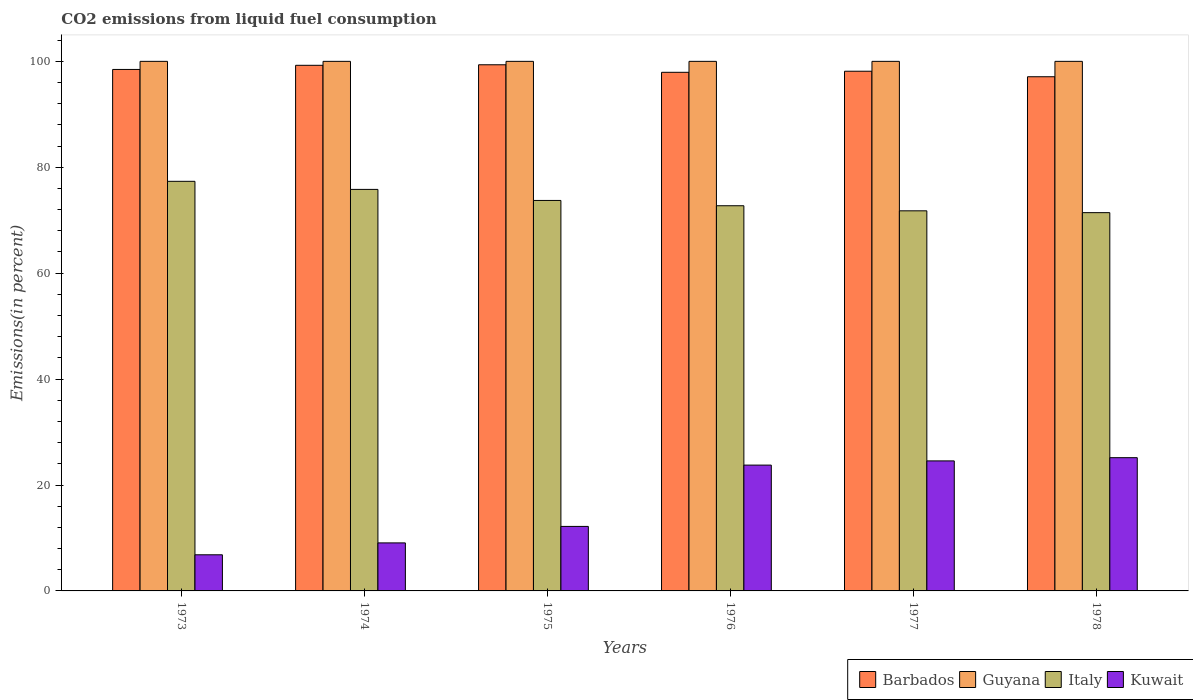How many different coloured bars are there?
Provide a succinct answer. 4. How many groups of bars are there?
Your response must be concise. 6. Are the number of bars on each tick of the X-axis equal?
Your response must be concise. Yes. How many bars are there on the 5th tick from the right?
Ensure brevity in your answer.  4. What is the label of the 6th group of bars from the left?
Provide a short and direct response. 1978. What is the total CO2 emitted in Guyana in 1973?
Offer a very short reply. 100. Across all years, what is the maximum total CO2 emitted in Italy?
Keep it short and to the point. 77.35. Across all years, what is the minimum total CO2 emitted in Kuwait?
Provide a succinct answer. 6.82. In which year was the total CO2 emitted in Barbados maximum?
Make the answer very short. 1975. In which year was the total CO2 emitted in Barbados minimum?
Keep it short and to the point. 1978. What is the total total CO2 emitted in Kuwait in the graph?
Offer a very short reply. 101.55. What is the difference between the total CO2 emitted in Kuwait in 1976 and that in 1977?
Make the answer very short. -0.79. What is the difference between the total CO2 emitted in Guyana in 1976 and the total CO2 emitted in Barbados in 1978?
Offer a terse response. 2.91. What is the average total CO2 emitted in Barbados per year?
Ensure brevity in your answer.  98.37. In the year 1973, what is the difference between the total CO2 emitted in Italy and total CO2 emitted in Guyana?
Keep it short and to the point. -22.65. In how many years, is the total CO2 emitted in Barbados greater than 88 %?
Your answer should be compact. 6. What is the ratio of the total CO2 emitted in Italy in 1974 to that in 1977?
Keep it short and to the point. 1.06. Is the total CO2 emitted in Kuwait in 1974 less than that in 1975?
Provide a short and direct response. Yes. What is the difference between the highest and the second highest total CO2 emitted in Italy?
Ensure brevity in your answer.  1.53. What is the difference between the highest and the lowest total CO2 emitted in Kuwait?
Provide a succinct answer. 18.34. What does the 4th bar from the left in 1978 represents?
Offer a very short reply. Kuwait. What does the 4th bar from the right in 1976 represents?
Provide a succinct answer. Barbados. Are all the bars in the graph horizontal?
Your response must be concise. No. What is the difference between two consecutive major ticks on the Y-axis?
Provide a short and direct response. 20. How many legend labels are there?
Your response must be concise. 4. How are the legend labels stacked?
Ensure brevity in your answer.  Horizontal. What is the title of the graph?
Keep it short and to the point. CO2 emissions from liquid fuel consumption. Does "Papua New Guinea" appear as one of the legend labels in the graph?
Keep it short and to the point. No. What is the label or title of the Y-axis?
Your answer should be very brief. Emissions(in percent). What is the Emissions(in percent) in Barbados in 1973?
Make the answer very short. 98.47. What is the Emissions(in percent) of Italy in 1973?
Keep it short and to the point. 77.35. What is the Emissions(in percent) in Kuwait in 1973?
Your response must be concise. 6.82. What is the Emissions(in percent) of Barbados in 1974?
Offer a terse response. 99.25. What is the Emissions(in percent) in Italy in 1974?
Provide a short and direct response. 75.82. What is the Emissions(in percent) of Kuwait in 1974?
Offer a terse response. 9.07. What is the Emissions(in percent) in Barbados in 1975?
Provide a succinct answer. 99.35. What is the Emissions(in percent) in Italy in 1975?
Provide a short and direct response. 73.73. What is the Emissions(in percent) of Kuwait in 1975?
Make the answer very short. 12.18. What is the Emissions(in percent) of Barbados in 1976?
Offer a very short reply. 97.93. What is the Emissions(in percent) of Guyana in 1976?
Give a very brief answer. 100. What is the Emissions(in percent) of Italy in 1976?
Provide a short and direct response. 72.73. What is the Emissions(in percent) in Kuwait in 1976?
Your response must be concise. 23.76. What is the Emissions(in percent) of Barbados in 1977?
Ensure brevity in your answer.  98.14. What is the Emissions(in percent) in Italy in 1977?
Your answer should be very brief. 71.77. What is the Emissions(in percent) of Kuwait in 1977?
Keep it short and to the point. 24.55. What is the Emissions(in percent) of Barbados in 1978?
Your answer should be very brief. 97.09. What is the Emissions(in percent) in Guyana in 1978?
Give a very brief answer. 100. What is the Emissions(in percent) of Italy in 1978?
Your answer should be compact. 71.43. What is the Emissions(in percent) of Kuwait in 1978?
Offer a terse response. 25.16. Across all years, what is the maximum Emissions(in percent) in Barbados?
Your answer should be compact. 99.35. Across all years, what is the maximum Emissions(in percent) of Guyana?
Keep it short and to the point. 100. Across all years, what is the maximum Emissions(in percent) of Italy?
Make the answer very short. 77.35. Across all years, what is the maximum Emissions(in percent) of Kuwait?
Ensure brevity in your answer.  25.16. Across all years, what is the minimum Emissions(in percent) of Barbados?
Your answer should be very brief. 97.09. Across all years, what is the minimum Emissions(in percent) of Guyana?
Your response must be concise. 100. Across all years, what is the minimum Emissions(in percent) in Italy?
Offer a terse response. 71.43. Across all years, what is the minimum Emissions(in percent) in Kuwait?
Make the answer very short. 6.82. What is the total Emissions(in percent) of Barbados in the graph?
Offer a terse response. 590.24. What is the total Emissions(in percent) of Guyana in the graph?
Ensure brevity in your answer.  600. What is the total Emissions(in percent) of Italy in the graph?
Your response must be concise. 442.84. What is the total Emissions(in percent) of Kuwait in the graph?
Offer a terse response. 101.55. What is the difference between the Emissions(in percent) of Barbados in 1973 and that in 1974?
Make the answer very short. -0.78. What is the difference between the Emissions(in percent) of Guyana in 1973 and that in 1974?
Give a very brief answer. 0. What is the difference between the Emissions(in percent) of Italy in 1973 and that in 1974?
Provide a short and direct response. 1.53. What is the difference between the Emissions(in percent) in Kuwait in 1973 and that in 1974?
Offer a terse response. -2.25. What is the difference between the Emissions(in percent) in Barbados in 1973 and that in 1975?
Keep it short and to the point. -0.88. What is the difference between the Emissions(in percent) of Guyana in 1973 and that in 1975?
Provide a succinct answer. 0. What is the difference between the Emissions(in percent) of Italy in 1973 and that in 1975?
Make the answer very short. 3.61. What is the difference between the Emissions(in percent) in Kuwait in 1973 and that in 1975?
Keep it short and to the point. -5.36. What is the difference between the Emissions(in percent) of Barbados in 1973 and that in 1976?
Ensure brevity in your answer.  0.54. What is the difference between the Emissions(in percent) in Guyana in 1973 and that in 1976?
Provide a succinct answer. 0. What is the difference between the Emissions(in percent) in Italy in 1973 and that in 1976?
Give a very brief answer. 4.61. What is the difference between the Emissions(in percent) of Kuwait in 1973 and that in 1976?
Offer a terse response. -16.94. What is the difference between the Emissions(in percent) of Barbados in 1973 and that in 1977?
Offer a very short reply. 0.34. What is the difference between the Emissions(in percent) of Italy in 1973 and that in 1977?
Make the answer very short. 5.57. What is the difference between the Emissions(in percent) in Kuwait in 1973 and that in 1977?
Offer a very short reply. -17.73. What is the difference between the Emissions(in percent) of Barbados in 1973 and that in 1978?
Your answer should be compact. 1.38. What is the difference between the Emissions(in percent) in Italy in 1973 and that in 1978?
Keep it short and to the point. 5.92. What is the difference between the Emissions(in percent) of Kuwait in 1973 and that in 1978?
Offer a very short reply. -18.34. What is the difference between the Emissions(in percent) in Barbados in 1974 and that in 1975?
Provide a succinct answer. -0.1. What is the difference between the Emissions(in percent) in Guyana in 1974 and that in 1975?
Ensure brevity in your answer.  0. What is the difference between the Emissions(in percent) of Italy in 1974 and that in 1975?
Make the answer very short. 2.09. What is the difference between the Emissions(in percent) of Kuwait in 1974 and that in 1975?
Your answer should be very brief. -3.11. What is the difference between the Emissions(in percent) in Barbados in 1974 and that in 1976?
Keep it short and to the point. 1.32. What is the difference between the Emissions(in percent) in Italy in 1974 and that in 1976?
Your answer should be compact. 3.09. What is the difference between the Emissions(in percent) of Kuwait in 1974 and that in 1976?
Provide a succinct answer. -14.69. What is the difference between the Emissions(in percent) in Barbados in 1974 and that in 1977?
Keep it short and to the point. 1.12. What is the difference between the Emissions(in percent) of Italy in 1974 and that in 1977?
Give a very brief answer. 4.05. What is the difference between the Emissions(in percent) of Kuwait in 1974 and that in 1977?
Your answer should be compact. -15.48. What is the difference between the Emissions(in percent) of Barbados in 1974 and that in 1978?
Provide a short and direct response. 2.16. What is the difference between the Emissions(in percent) of Guyana in 1974 and that in 1978?
Your response must be concise. 0. What is the difference between the Emissions(in percent) of Italy in 1974 and that in 1978?
Make the answer very short. 4.39. What is the difference between the Emissions(in percent) in Kuwait in 1974 and that in 1978?
Your response must be concise. -16.09. What is the difference between the Emissions(in percent) in Barbados in 1975 and that in 1976?
Provide a short and direct response. 1.42. What is the difference between the Emissions(in percent) of Guyana in 1975 and that in 1976?
Your answer should be very brief. 0. What is the difference between the Emissions(in percent) in Italy in 1975 and that in 1976?
Your response must be concise. 1. What is the difference between the Emissions(in percent) in Kuwait in 1975 and that in 1976?
Provide a succinct answer. -11.58. What is the difference between the Emissions(in percent) of Barbados in 1975 and that in 1977?
Offer a very short reply. 1.22. What is the difference between the Emissions(in percent) of Italy in 1975 and that in 1977?
Your response must be concise. 1.96. What is the difference between the Emissions(in percent) in Kuwait in 1975 and that in 1977?
Your answer should be compact. -12.37. What is the difference between the Emissions(in percent) of Barbados in 1975 and that in 1978?
Keep it short and to the point. 2.26. What is the difference between the Emissions(in percent) in Italy in 1975 and that in 1978?
Give a very brief answer. 2.3. What is the difference between the Emissions(in percent) of Kuwait in 1975 and that in 1978?
Offer a very short reply. -12.98. What is the difference between the Emissions(in percent) in Barbados in 1976 and that in 1977?
Your answer should be very brief. -0.21. What is the difference between the Emissions(in percent) of Guyana in 1976 and that in 1977?
Ensure brevity in your answer.  0. What is the difference between the Emissions(in percent) in Italy in 1976 and that in 1977?
Offer a very short reply. 0.96. What is the difference between the Emissions(in percent) of Kuwait in 1976 and that in 1977?
Ensure brevity in your answer.  -0.79. What is the difference between the Emissions(in percent) in Barbados in 1976 and that in 1978?
Ensure brevity in your answer.  0.84. What is the difference between the Emissions(in percent) in Italy in 1976 and that in 1978?
Offer a very short reply. 1.3. What is the difference between the Emissions(in percent) of Kuwait in 1976 and that in 1978?
Offer a terse response. -1.4. What is the difference between the Emissions(in percent) of Barbados in 1977 and that in 1978?
Offer a terse response. 1.04. What is the difference between the Emissions(in percent) of Italy in 1977 and that in 1978?
Make the answer very short. 0.34. What is the difference between the Emissions(in percent) in Kuwait in 1977 and that in 1978?
Make the answer very short. -0.61. What is the difference between the Emissions(in percent) of Barbados in 1973 and the Emissions(in percent) of Guyana in 1974?
Provide a short and direct response. -1.53. What is the difference between the Emissions(in percent) in Barbados in 1973 and the Emissions(in percent) in Italy in 1974?
Your response must be concise. 22.65. What is the difference between the Emissions(in percent) of Barbados in 1973 and the Emissions(in percent) of Kuwait in 1974?
Make the answer very short. 89.4. What is the difference between the Emissions(in percent) of Guyana in 1973 and the Emissions(in percent) of Italy in 1974?
Offer a terse response. 24.18. What is the difference between the Emissions(in percent) in Guyana in 1973 and the Emissions(in percent) in Kuwait in 1974?
Offer a very short reply. 90.93. What is the difference between the Emissions(in percent) of Italy in 1973 and the Emissions(in percent) of Kuwait in 1974?
Provide a succinct answer. 68.28. What is the difference between the Emissions(in percent) of Barbados in 1973 and the Emissions(in percent) of Guyana in 1975?
Provide a succinct answer. -1.53. What is the difference between the Emissions(in percent) in Barbados in 1973 and the Emissions(in percent) in Italy in 1975?
Offer a very short reply. 24.74. What is the difference between the Emissions(in percent) in Barbados in 1973 and the Emissions(in percent) in Kuwait in 1975?
Offer a very short reply. 86.29. What is the difference between the Emissions(in percent) in Guyana in 1973 and the Emissions(in percent) in Italy in 1975?
Offer a terse response. 26.27. What is the difference between the Emissions(in percent) of Guyana in 1973 and the Emissions(in percent) of Kuwait in 1975?
Offer a very short reply. 87.82. What is the difference between the Emissions(in percent) in Italy in 1973 and the Emissions(in percent) in Kuwait in 1975?
Offer a terse response. 65.16. What is the difference between the Emissions(in percent) of Barbados in 1973 and the Emissions(in percent) of Guyana in 1976?
Your answer should be very brief. -1.53. What is the difference between the Emissions(in percent) of Barbados in 1973 and the Emissions(in percent) of Italy in 1976?
Your answer should be compact. 25.74. What is the difference between the Emissions(in percent) of Barbados in 1973 and the Emissions(in percent) of Kuwait in 1976?
Ensure brevity in your answer.  74.71. What is the difference between the Emissions(in percent) in Guyana in 1973 and the Emissions(in percent) in Italy in 1976?
Your answer should be very brief. 27.27. What is the difference between the Emissions(in percent) in Guyana in 1973 and the Emissions(in percent) in Kuwait in 1976?
Your response must be concise. 76.24. What is the difference between the Emissions(in percent) in Italy in 1973 and the Emissions(in percent) in Kuwait in 1976?
Make the answer very short. 53.59. What is the difference between the Emissions(in percent) of Barbados in 1973 and the Emissions(in percent) of Guyana in 1977?
Provide a short and direct response. -1.53. What is the difference between the Emissions(in percent) in Barbados in 1973 and the Emissions(in percent) in Italy in 1977?
Make the answer very short. 26.7. What is the difference between the Emissions(in percent) in Barbados in 1973 and the Emissions(in percent) in Kuwait in 1977?
Offer a very short reply. 73.92. What is the difference between the Emissions(in percent) in Guyana in 1973 and the Emissions(in percent) in Italy in 1977?
Your answer should be compact. 28.23. What is the difference between the Emissions(in percent) of Guyana in 1973 and the Emissions(in percent) of Kuwait in 1977?
Offer a terse response. 75.45. What is the difference between the Emissions(in percent) of Italy in 1973 and the Emissions(in percent) of Kuwait in 1977?
Offer a very short reply. 52.79. What is the difference between the Emissions(in percent) in Barbados in 1973 and the Emissions(in percent) in Guyana in 1978?
Your answer should be very brief. -1.53. What is the difference between the Emissions(in percent) of Barbados in 1973 and the Emissions(in percent) of Italy in 1978?
Your answer should be compact. 27.04. What is the difference between the Emissions(in percent) in Barbados in 1973 and the Emissions(in percent) in Kuwait in 1978?
Provide a succinct answer. 73.31. What is the difference between the Emissions(in percent) of Guyana in 1973 and the Emissions(in percent) of Italy in 1978?
Provide a short and direct response. 28.57. What is the difference between the Emissions(in percent) in Guyana in 1973 and the Emissions(in percent) in Kuwait in 1978?
Offer a very short reply. 74.84. What is the difference between the Emissions(in percent) of Italy in 1973 and the Emissions(in percent) of Kuwait in 1978?
Make the answer very short. 52.18. What is the difference between the Emissions(in percent) of Barbados in 1974 and the Emissions(in percent) of Guyana in 1975?
Keep it short and to the point. -0.75. What is the difference between the Emissions(in percent) of Barbados in 1974 and the Emissions(in percent) of Italy in 1975?
Your answer should be very brief. 25.52. What is the difference between the Emissions(in percent) of Barbados in 1974 and the Emissions(in percent) of Kuwait in 1975?
Ensure brevity in your answer.  87.07. What is the difference between the Emissions(in percent) of Guyana in 1974 and the Emissions(in percent) of Italy in 1975?
Provide a short and direct response. 26.27. What is the difference between the Emissions(in percent) in Guyana in 1974 and the Emissions(in percent) in Kuwait in 1975?
Your response must be concise. 87.82. What is the difference between the Emissions(in percent) in Italy in 1974 and the Emissions(in percent) in Kuwait in 1975?
Offer a very short reply. 63.64. What is the difference between the Emissions(in percent) in Barbados in 1974 and the Emissions(in percent) in Guyana in 1976?
Provide a short and direct response. -0.75. What is the difference between the Emissions(in percent) in Barbados in 1974 and the Emissions(in percent) in Italy in 1976?
Make the answer very short. 26.52. What is the difference between the Emissions(in percent) in Barbados in 1974 and the Emissions(in percent) in Kuwait in 1976?
Provide a short and direct response. 75.49. What is the difference between the Emissions(in percent) of Guyana in 1974 and the Emissions(in percent) of Italy in 1976?
Offer a very short reply. 27.27. What is the difference between the Emissions(in percent) in Guyana in 1974 and the Emissions(in percent) in Kuwait in 1976?
Provide a succinct answer. 76.24. What is the difference between the Emissions(in percent) in Italy in 1974 and the Emissions(in percent) in Kuwait in 1976?
Offer a very short reply. 52.06. What is the difference between the Emissions(in percent) of Barbados in 1974 and the Emissions(in percent) of Guyana in 1977?
Your response must be concise. -0.75. What is the difference between the Emissions(in percent) in Barbados in 1974 and the Emissions(in percent) in Italy in 1977?
Keep it short and to the point. 27.48. What is the difference between the Emissions(in percent) in Barbados in 1974 and the Emissions(in percent) in Kuwait in 1977?
Offer a terse response. 74.7. What is the difference between the Emissions(in percent) in Guyana in 1974 and the Emissions(in percent) in Italy in 1977?
Offer a terse response. 28.23. What is the difference between the Emissions(in percent) of Guyana in 1974 and the Emissions(in percent) of Kuwait in 1977?
Keep it short and to the point. 75.45. What is the difference between the Emissions(in percent) in Italy in 1974 and the Emissions(in percent) in Kuwait in 1977?
Offer a very short reply. 51.27. What is the difference between the Emissions(in percent) of Barbados in 1974 and the Emissions(in percent) of Guyana in 1978?
Your response must be concise. -0.75. What is the difference between the Emissions(in percent) in Barbados in 1974 and the Emissions(in percent) in Italy in 1978?
Offer a very short reply. 27.82. What is the difference between the Emissions(in percent) of Barbados in 1974 and the Emissions(in percent) of Kuwait in 1978?
Your response must be concise. 74.09. What is the difference between the Emissions(in percent) of Guyana in 1974 and the Emissions(in percent) of Italy in 1978?
Make the answer very short. 28.57. What is the difference between the Emissions(in percent) of Guyana in 1974 and the Emissions(in percent) of Kuwait in 1978?
Ensure brevity in your answer.  74.84. What is the difference between the Emissions(in percent) of Italy in 1974 and the Emissions(in percent) of Kuwait in 1978?
Offer a terse response. 50.66. What is the difference between the Emissions(in percent) of Barbados in 1975 and the Emissions(in percent) of Guyana in 1976?
Provide a succinct answer. -0.65. What is the difference between the Emissions(in percent) of Barbados in 1975 and the Emissions(in percent) of Italy in 1976?
Make the answer very short. 26.62. What is the difference between the Emissions(in percent) in Barbados in 1975 and the Emissions(in percent) in Kuwait in 1976?
Provide a short and direct response. 75.6. What is the difference between the Emissions(in percent) in Guyana in 1975 and the Emissions(in percent) in Italy in 1976?
Your response must be concise. 27.27. What is the difference between the Emissions(in percent) of Guyana in 1975 and the Emissions(in percent) of Kuwait in 1976?
Make the answer very short. 76.24. What is the difference between the Emissions(in percent) in Italy in 1975 and the Emissions(in percent) in Kuwait in 1976?
Your response must be concise. 49.97. What is the difference between the Emissions(in percent) of Barbados in 1975 and the Emissions(in percent) of Guyana in 1977?
Provide a short and direct response. -0.65. What is the difference between the Emissions(in percent) of Barbados in 1975 and the Emissions(in percent) of Italy in 1977?
Offer a terse response. 27.58. What is the difference between the Emissions(in percent) of Barbados in 1975 and the Emissions(in percent) of Kuwait in 1977?
Offer a terse response. 74.8. What is the difference between the Emissions(in percent) in Guyana in 1975 and the Emissions(in percent) in Italy in 1977?
Give a very brief answer. 28.23. What is the difference between the Emissions(in percent) in Guyana in 1975 and the Emissions(in percent) in Kuwait in 1977?
Offer a very short reply. 75.45. What is the difference between the Emissions(in percent) in Italy in 1975 and the Emissions(in percent) in Kuwait in 1977?
Offer a terse response. 49.18. What is the difference between the Emissions(in percent) in Barbados in 1975 and the Emissions(in percent) in Guyana in 1978?
Your answer should be very brief. -0.65. What is the difference between the Emissions(in percent) of Barbados in 1975 and the Emissions(in percent) of Italy in 1978?
Give a very brief answer. 27.92. What is the difference between the Emissions(in percent) of Barbados in 1975 and the Emissions(in percent) of Kuwait in 1978?
Your response must be concise. 74.19. What is the difference between the Emissions(in percent) of Guyana in 1975 and the Emissions(in percent) of Italy in 1978?
Provide a short and direct response. 28.57. What is the difference between the Emissions(in percent) in Guyana in 1975 and the Emissions(in percent) in Kuwait in 1978?
Offer a terse response. 74.84. What is the difference between the Emissions(in percent) of Italy in 1975 and the Emissions(in percent) of Kuwait in 1978?
Offer a very short reply. 48.57. What is the difference between the Emissions(in percent) of Barbados in 1976 and the Emissions(in percent) of Guyana in 1977?
Ensure brevity in your answer.  -2.07. What is the difference between the Emissions(in percent) of Barbados in 1976 and the Emissions(in percent) of Italy in 1977?
Keep it short and to the point. 26.16. What is the difference between the Emissions(in percent) in Barbados in 1976 and the Emissions(in percent) in Kuwait in 1977?
Your response must be concise. 73.38. What is the difference between the Emissions(in percent) of Guyana in 1976 and the Emissions(in percent) of Italy in 1977?
Your response must be concise. 28.23. What is the difference between the Emissions(in percent) in Guyana in 1976 and the Emissions(in percent) in Kuwait in 1977?
Provide a short and direct response. 75.45. What is the difference between the Emissions(in percent) of Italy in 1976 and the Emissions(in percent) of Kuwait in 1977?
Offer a terse response. 48.18. What is the difference between the Emissions(in percent) of Barbados in 1976 and the Emissions(in percent) of Guyana in 1978?
Provide a short and direct response. -2.07. What is the difference between the Emissions(in percent) of Barbados in 1976 and the Emissions(in percent) of Italy in 1978?
Make the answer very short. 26.5. What is the difference between the Emissions(in percent) in Barbados in 1976 and the Emissions(in percent) in Kuwait in 1978?
Make the answer very short. 72.77. What is the difference between the Emissions(in percent) in Guyana in 1976 and the Emissions(in percent) in Italy in 1978?
Your answer should be very brief. 28.57. What is the difference between the Emissions(in percent) of Guyana in 1976 and the Emissions(in percent) of Kuwait in 1978?
Provide a short and direct response. 74.84. What is the difference between the Emissions(in percent) in Italy in 1976 and the Emissions(in percent) in Kuwait in 1978?
Provide a succinct answer. 47.57. What is the difference between the Emissions(in percent) in Barbados in 1977 and the Emissions(in percent) in Guyana in 1978?
Your answer should be compact. -1.86. What is the difference between the Emissions(in percent) of Barbados in 1977 and the Emissions(in percent) of Italy in 1978?
Make the answer very short. 26.71. What is the difference between the Emissions(in percent) of Barbados in 1977 and the Emissions(in percent) of Kuwait in 1978?
Your answer should be very brief. 72.98. What is the difference between the Emissions(in percent) of Guyana in 1977 and the Emissions(in percent) of Italy in 1978?
Provide a short and direct response. 28.57. What is the difference between the Emissions(in percent) in Guyana in 1977 and the Emissions(in percent) in Kuwait in 1978?
Your answer should be very brief. 74.84. What is the difference between the Emissions(in percent) of Italy in 1977 and the Emissions(in percent) of Kuwait in 1978?
Provide a succinct answer. 46.61. What is the average Emissions(in percent) in Barbados per year?
Your answer should be compact. 98.37. What is the average Emissions(in percent) of Guyana per year?
Keep it short and to the point. 100. What is the average Emissions(in percent) of Italy per year?
Your answer should be compact. 73.81. What is the average Emissions(in percent) in Kuwait per year?
Give a very brief answer. 16.92. In the year 1973, what is the difference between the Emissions(in percent) in Barbados and Emissions(in percent) in Guyana?
Your answer should be compact. -1.53. In the year 1973, what is the difference between the Emissions(in percent) of Barbados and Emissions(in percent) of Italy?
Offer a very short reply. 21.13. In the year 1973, what is the difference between the Emissions(in percent) of Barbados and Emissions(in percent) of Kuwait?
Give a very brief answer. 91.65. In the year 1973, what is the difference between the Emissions(in percent) of Guyana and Emissions(in percent) of Italy?
Your answer should be very brief. 22.65. In the year 1973, what is the difference between the Emissions(in percent) in Guyana and Emissions(in percent) in Kuwait?
Provide a succinct answer. 93.18. In the year 1973, what is the difference between the Emissions(in percent) in Italy and Emissions(in percent) in Kuwait?
Offer a terse response. 70.52. In the year 1974, what is the difference between the Emissions(in percent) in Barbados and Emissions(in percent) in Guyana?
Offer a terse response. -0.75. In the year 1974, what is the difference between the Emissions(in percent) in Barbados and Emissions(in percent) in Italy?
Your response must be concise. 23.43. In the year 1974, what is the difference between the Emissions(in percent) in Barbados and Emissions(in percent) in Kuwait?
Your answer should be very brief. 90.19. In the year 1974, what is the difference between the Emissions(in percent) in Guyana and Emissions(in percent) in Italy?
Provide a succinct answer. 24.18. In the year 1974, what is the difference between the Emissions(in percent) of Guyana and Emissions(in percent) of Kuwait?
Keep it short and to the point. 90.93. In the year 1974, what is the difference between the Emissions(in percent) of Italy and Emissions(in percent) of Kuwait?
Provide a succinct answer. 66.75. In the year 1975, what is the difference between the Emissions(in percent) of Barbados and Emissions(in percent) of Guyana?
Give a very brief answer. -0.65. In the year 1975, what is the difference between the Emissions(in percent) in Barbados and Emissions(in percent) in Italy?
Offer a very short reply. 25.62. In the year 1975, what is the difference between the Emissions(in percent) in Barbados and Emissions(in percent) in Kuwait?
Provide a succinct answer. 87.17. In the year 1975, what is the difference between the Emissions(in percent) of Guyana and Emissions(in percent) of Italy?
Keep it short and to the point. 26.27. In the year 1975, what is the difference between the Emissions(in percent) of Guyana and Emissions(in percent) of Kuwait?
Ensure brevity in your answer.  87.82. In the year 1975, what is the difference between the Emissions(in percent) of Italy and Emissions(in percent) of Kuwait?
Provide a short and direct response. 61.55. In the year 1976, what is the difference between the Emissions(in percent) in Barbados and Emissions(in percent) in Guyana?
Your response must be concise. -2.07. In the year 1976, what is the difference between the Emissions(in percent) of Barbados and Emissions(in percent) of Italy?
Provide a succinct answer. 25.2. In the year 1976, what is the difference between the Emissions(in percent) of Barbados and Emissions(in percent) of Kuwait?
Your response must be concise. 74.17. In the year 1976, what is the difference between the Emissions(in percent) in Guyana and Emissions(in percent) in Italy?
Give a very brief answer. 27.27. In the year 1976, what is the difference between the Emissions(in percent) in Guyana and Emissions(in percent) in Kuwait?
Make the answer very short. 76.24. In the year 1976, what is the difference between the Emissions(in percent) of Italy and Emissions(in percent) of Kuwait?
Make the answer very short. 48.97. In the year 1977, what is the difference between the Emissions(in percent) in Barbados and Emissions(in percent) in Guyana?
Make the answer very short. -1.86. In the year 1977, what is the difference between the Emissions(in percent) in Barbados and Emissions(in percent) in Italy?
Give a very brief answer. 26.36. In the year 1977, what is the difference between the Emissions(in percent) of Barbados and Emissions(in percent) of Kuwait?
Offer a terse response. 73.58. In the year 1977, what is the difference between the Emissions(in percent) in Guyana and Emissions(in percent) in Italy?
Provide a succinct answer. 28.23. In the year 1977, what is the difference between the Emissions(in percent) of Guyana and Emissions(in percent) of Kuwait?
Provide a succinct answer. 75.45. In the year 1977, what is the difference between the Emissions(in percent) in Italy and Emissions(in percent) in Kuwait?
Make the answer very short. 47.22. In the year 1978, what is the difference between the Emissions(in percent) of Barbados and Emissions(in percent) of Guyana?
Make the answer very short. -2.91. In the year 1978, what is the difference between the Emissions(in percent) of Barbados and Emissions(in percent) of Italy?
Your answer should be very brief. 25.66. In the year 1978, what is the difference between the Emissions(in percent) of Barbados and Emissions(in percent) of Kuwait?
Keep it short and to the point. 71.93. In the year 1978, what is the difference between the Emissions(in percent) in Guyana and Emissions(in percent) in Italy?
Your answer should be compact. 28.57. In the year 1978, what is the difference between the Emissions(in percent) in Guyana and Emissions(in percent) in Kuwait?
Ensure brevity in your answer.  74.84. In the year 1978, what is the difference between the Emissions(in percent) in Italy and Emissions(in percent) in Kuwait?
Offer a terse response. 46.27. What is the ratio of the Emissions(in percent) in Barbados in 1973 to that in 1974?
Offer a very short reply. 0.99. What is the ratio of the Emissions(in percent) in Guyana in 1973 to that in 1974?
Offer a terse response. 1. What is the ratio of the Emissions(in percent) of Italy in 1973 to that in 1974?
Offer a very short reply. 1.02. What is the ratio of the Emissions(in percent) of Kuwait in 1973 to that in 1974?
Your response must be concise. 0.75. What is the ratio of the Emissions(in percent) of Barbados in 1973 to that in 1975?
Your answer should be very brief. 0.99. What is the ratio of the Emissions(in percent) in Guyana in 1973 to that in 1975?
Offer a terse response. 1. What is the ratio of the Emissions(in percent) of Italy in 1973 to that in 1975?
Provide a succinct answer. 1.05. What is the ratio of the Emissions(in percent) of Kuwait in 1973 to that in 1975?
Give a very brief answer. 0.56. What is the ratio of the Emissions(in percent) of Barbados in 1973 to that in 1976?
Provide a short and direct response. 1.01. What is the ratio of the Emissions(in percent) in Guyana in 1973 to that in 1976?
Your response must be concise. 1. What is the ratio of the Emissions(in percent) in Italy in 1973 to that in 1976?
Keep it short and to the point. 1.06. What is the ratio of the Emissions(in percent) of Kuwait in 1973 to that in 1976?
Give a very brief answer. 0.29. What is the ratio of the Emissions(in percent) in Italy in 1973 to that in 1977?
Give a very brief answer. 1.08. What is the ratio of the Emissions(in percent) of Kuwait in 1973 to that in 1977?
Your answer should be compact. 0.28. What is the ratio of the Emissions(in percent) in Barbados in 1973 to that in 1978?
Offer a very short reply. 1.01. What is the ratio of the Emissions(in percent) in Italy in 1973 to that in 1978?
Your response must be concise. 1.08. What is the ratio of the Emissions(in percent) of Kuwait in 1973 to that in 1978?
Ensure brevity in your answer.  0.27. What is the ratio of the Emissions(in percent) of Italy in 1974 to that in 1975?
Your answer should be very brief. 1.03. What is the ratio of the Emissions(in percent) of Kuwait in 1974 to that in 1975?
Your answer should be compact. 0.74. What is the ratio of the Emissions(in percent) in Barbados in 1974 to that in 1976?
Provide a succinct answer. 1.01. What is the ratio of the Emissions(in percent) of Italy in 1974 to that in 1976?
Your answer should be compact. 1.04. What is the ratio of the Emissions(in percent) in Kuwait in 1974 to that in 1976?
Your answer should be very brief. 0.38. What is the ratio of the Emissions(in percent) of Barbados in 1974 to that in 1977?
Your response must be concise. 1.01. What is the ratio of the Emissions(in percent) in Italy in 1974 to that in 1977?
Ensure brevity in your answer.  1.06. What is the ratio of the Emissions(in percent) of Kuwait in 1974 to that in 1977?
Offer a terse response. 0.37. What is the ratio of the Emissions(in percent) of Barbados in 1974 to that in 1978?
Make the answer very short. 1.02. What is the ratio of the Emissions(in percent) in Italy in 1974 to that in 1978?
Offer a very short reply. 1.06. What is the ratio of the Emissions(in percent) in Kuwait in 1974 to that in 1978?
Offer a very short reply. 0.36. What is the ratio of the Emissions(in percent) in Barbados in 1975 to that in 1976?
Ensure brevity in your answer.  1.01. What is the ratio of the Emissions(in percent) of Guyana in 1975 to that in 1976?
Your answer should be very brief. 1. What is the ratio of the Emissions(in percent) in Italy in 1975 to that in 1976?
Provide a short and direct response. 1.01. What is the ratio of the Emissions(in percent) of Kuwait in 1975 to that in 1976?
Offer a terse response. 0.51. What is the ratio of the Emissions(in percent) in Barbados in 1975 to that in 1977?
Offer a terse response. 1.01. What is the ratio of the Emissions(in percent) of Guyana in 1975 to that in 1977?
Ensure brevity in your answer.  1. What is the ratio of the Emissions(in percent) of Italy in 1975 to that in 1977?
Ensure brevity in your answer.  1.03. What is the ratio of the Emissions(in percent) of Kuwait in 1975 to that in 1977?
Your answer should be very brief. 0.5. What is the ratio of the Emissions(in percent) in Barbados in 1975 to that in 1978?
Your answer should be compact. 1.02. What is the ratio of the Emissions(in percent) in Italy in 1975 to that in 1978?
Provide a short and direct response. 1.03. What is the ratio of the Emissions(in percent) in Kuwait in 1975 to that in 1978?
Keep it short and to the point. 0.48. What is the ratio of the Emissions(in percent) in Barbados in 1976 to that in 1977?
Your response must be concise. 1. What is the ratio of the Emissions(in percent) of Guyana in 1976 to that in 1977?
Provide a short and direct response. 1. What is the ratio of the Emissions(in percent) in Italy in 1976 to that in 1977?
Give a very brief answer. 1.01. What is the ratio of the Emissions(in percent) of Barbados in 1976 to that in 1978?
Offer a terse response. 1.01. What is the ratio of the Emissions(in percent) of Guyana in 1976 to that in 1978?
Provide a succinct answer. 1. What is the ratio of the Emissions(in percent) of Italy in 1976 to that in 1978?
Give a very brief answer. 1.02. What is the ratio of the Emissions(in percent) in Kuwait in 1976 to that in 1978?
Make the answer very short. 0.94. What is the ratio of the Emissions(in percent) of Barbados in 1977 to that in 1978?
Your answer should be very brief. 1.01. What is the ratio of the Emissions(in percent) of Kuwait in 1977 to that in 1978?
Your answer should be very brief. 0.98. What is the difference between the highest and the second highest Emissions(in percent) of Barbados?
Make the answer very short. 0.1. What is the difference between the highest and the second highest Emissions(in percent) of Italy?
Offer a very short reply. 1.53. What is the difference between the highest and the second highest Emissions(in percent) in Kuwait?
Your response must be concise. 0.61. What is the difference between the highest and the lowest Emissions(in percent) in Barbados?
Give a very brief answer. 2.26. What is the difference between the highest and the lowest Emissions(in percent) in Italy?
Provide a short and direct response. 5.92. What is the difference between the highest and the lowest Emissions(in percent) in Kuwait?
Make the answer very short. 18.34. 